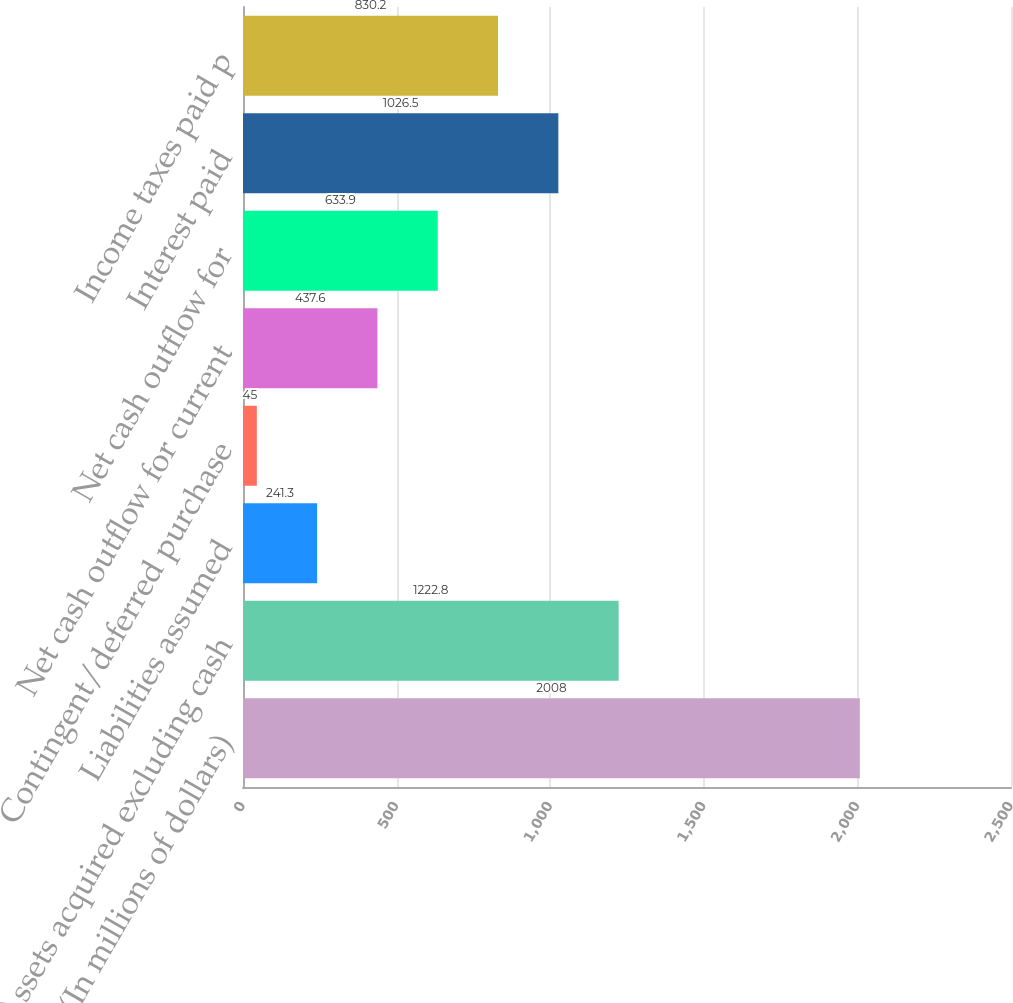Convert chart. <chart><loc_0><loc_0><loc_500><loc_500><bar_chart><fcel>(In millions of dollars)<fcel>Assets acquired excluding cash<fcel>Liabilities assumed<fcel>Contingent/deferred purchase<fcel>Net cash outflow for current<fcel>Net cash outflow for<fcel>Interest paid<fcel>Income taxes paid p<nl><fcel>2008<fcel>1222.8<fcel>241.3<fcel>45<fcel>437.6<fcel>633.9<fcel>1026.5<fcel>830.2<nl></chart> 